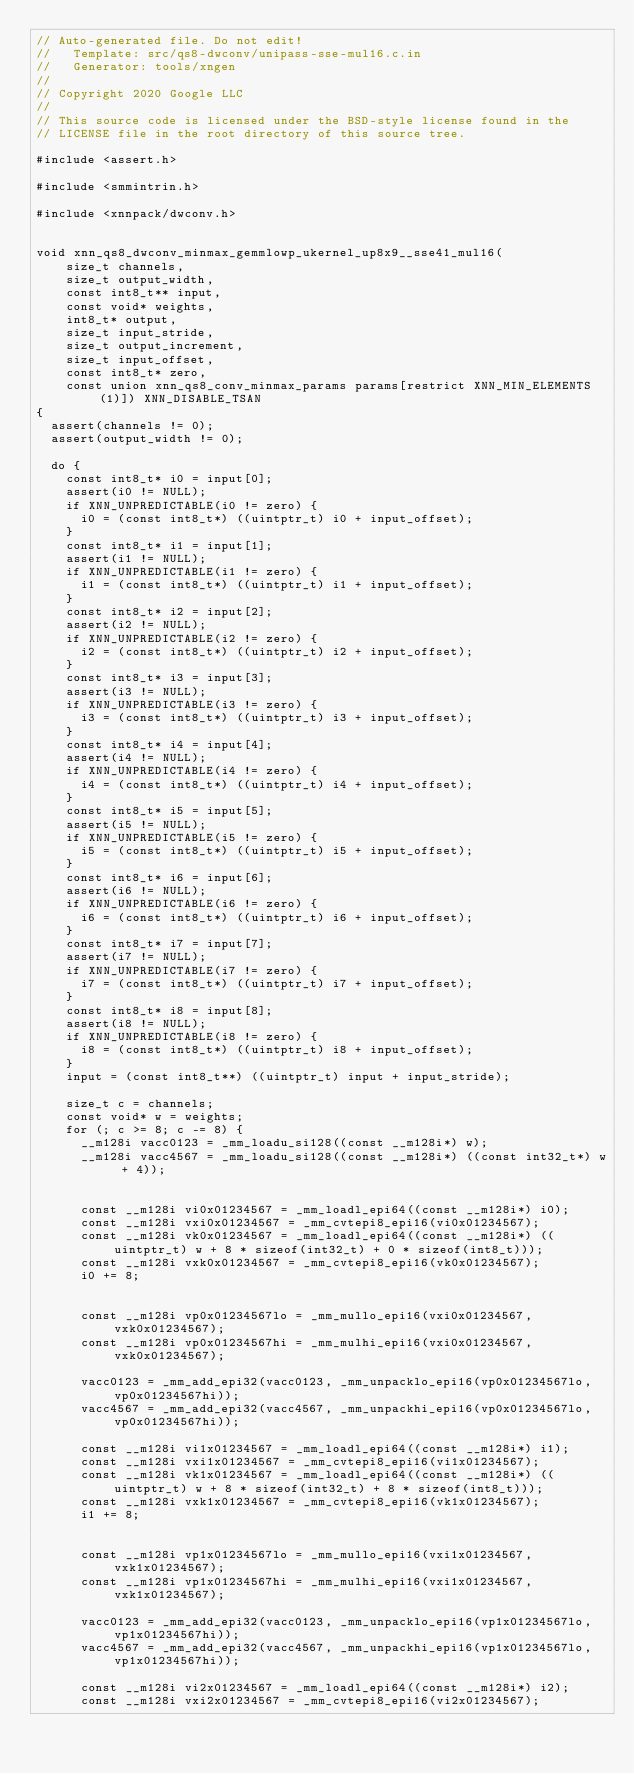<code> <loc_0><loc_0><loc_500><loc_500><_C_>// Auto-generated file. Do not edit!
//   Template: src/qs8-dwconv/unipass-sse-mul16.c.in
//   Generator: tools/xngen
//
// Copyright 2020 Google LLC
//
// This source code is licensed under the BSD-style license found in the
// LICENSE file in the root directory of this source tree.

#include <assert.h>

#include <smmintrin.h>

#include <xnnpack/dwconv.h>


void xnn_qs8_dwconv_minmax_gemmlowp_ukernel_up8x9__sse41_mul16(
    size_t channels,
    size_t output_width,
    const int8_t** input,
    const void* weights,
    int8_t* output,
    size_t input_stride,
    size_t output_increment,
    size_t input_offset,
    const int8_t* zero,
    const union xnn_qs8_conv_minmax_params params[restrict XNN_MIN_ELEMENTS(1)]) XNN_DISABLE_TSAN
{
  assert(channels != 0);
  assert(output_width != 0);

  do {
    const int8_t* i0 = input[0];
    assert(i0 != NULL);
    if XNN_UNPREDICTABLE(i0 != zero) {
      i0 = (const int8_t*) ((uintptr_t) i0 + input_offset);
    }
    const int8_t* i1 = input[1];
    assert(i1 != NULL);
    if XNN_UNPREDICTABLE(i1 != zero) {
      i1 = (const int8_t*) ((uintptr_t) i1 + input_offset);
    }
    const int8_t* i2 = input[2];
    assert(i2 != NULL);
    if XNN_UNPREDICTABLE(i2 != zero) {
      i2 = (const int8_t*) ((uintptr_t) i2 + input_offset);
    }
    const int8_t* i3 = input[3];
    assert(i3 != NULL);
    if XNN_UNPREDICTABLE(i3 != zero) {
      i3 = (const int8_t*) ((uintptr_t) i3 + input_offset);
    }
    const int8_t* i4 = input[4];
    assert(i4 != NULL);
    if XNN_UNPREDICTABLE(i4 != zero) {
      i4 = (const int8_t*) ((uintptr_t) i4 + input_offset);
    }
    const int8_t* i5 = input[5];
    assert(i5 != NULL);
    if XNN_UNPREDICTABLE(i5 != zero) {
      i5 = (const int8_t*) ((uintptr_t) i5 + input_offset);
    }
    const int8_t* i6 = input[6];
    assert(i6 != NULL);
    if XNN_UNPREDICTABLE(i6 != zero) {
      i6 = (const int8_t*) ((uintptr_t) i6 + input_offset);
    }
    const int8_t* i7 = input[7];
    assert(i7 != NULL);
    if XNN_UNPREDICTABLE(i7 != zero) {
      i7 = (const int8_t*) ((uintptr_t) i7 + input_offset);
    }
    const int8_t* i8 = input[8];
    assert(i8 != NULL);
    if XNN_UNPREDICTABLE(i8 != zero) {
      i8 = (const int8_t*) ((uintptr_t) i8 + input_offset);
    }
    input = (const int8_t**) ((uintptr_t) input + input_stride);

    size_t c = channels;
    const void* w = weights;
    for (; c >= 8; c -= 8) {
      __m128i vacc0123 = _mm_loadu_si128((const __m128i*) w);
      __m128i vacc4567 = _mm_loadu_si128((const __m128i*) ((const int32_t*) w + 4));


      const __m128i vi0x01234567 = _mm_loadl_epi64((const __m128i*) i0);
      const __m128i vxi0x01234567 = _mm_cvtepi8_epi16(vi0x01234567);
      const __m128i vk0x01234567 = _mm_loadl_epi64((const __m128i*) ((uintptr_t) w + 8 * sizeof(int32_t) + 0 * sizeof(int8_t)));
      const __m128i vxk0x01234567 = _mm_cvtepi8_epi16(vk0x01234567);
      i0 += 8;


      const __m128i vp0x01234567lo = _mm_mullo_epi16(vxi0x01234567, vxk0x01234567);
      const __m128i vp0x01234567hi = _mm_mulhi_epi16(vxi0x01234567, vxk0x01234567);

      vacc0123 = _mm_add_epi32(vacc0123, _mm_unpacklo_epi16(vp0x01234567lo, vp0x01234567hi));
      vacc4567 = _mm_add_epi32(vacc4567, _mm_unpackhi_epi16(vp0x01234567lo, vp0x01234567hi));

      const __m128i vi1x01234567 = _mm_loadl_epi64((const __m128i*) i1);
      const __m128i vxi1x01234567 = _mm_cvtepi8_epi16(vi1x01234567);
      const __m128i vk1x01234567 = _mm_loadl_epi64((const __m128i*) ((uintptr_t) w + 8 * sizeof(int32_t) + 8 * sizeof(int8_t)));
      const __m128i vxk1x01234567 = _mm_cvtepi8_epi16(vk1x01234567);
      i1 += 8;


      const __m128i vp1x01234567lo = _mm_mullo_epi16(vxi1x01234567, vxk1x01234567);
      const __m128i vp1x01234567hi = _mm_mulhi_epi16(vxi1x01234567, vxk1x01234567);

      vacc0123 = _mm_add_epi32(vacc0123, _mm_unpacklo_epi16(vp1x01234567lo, vp1x01234567hi));
      vacc4567 = _mm_add_epi32(vacc4567, _mm_unpackhi_epi16(vp1x01234567lo, vp1x01234567hi));

      const __m128i vi2x01234567 = _mm_loadl_epi64((const __m128i*) i2);
      const __m128i vxi2x01234567 = _mm_cvtepi8_epi16(vi2x01234567);</code> 